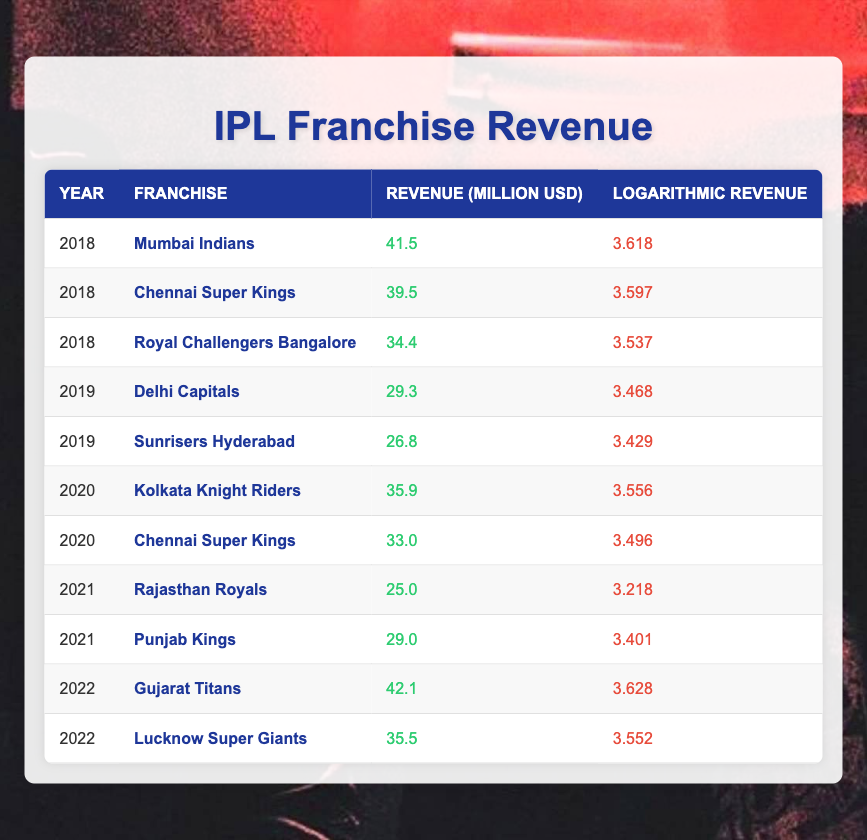What was the highest revenue generated by an IPL franchise in 2022? In 2022, the franchise with the highest revenue was Gujarat Titans, with a revenue of 42.1 million USD.
Answer: 42.1 million USD Which franchise had the lowest revenue in 2021? The franchise with the lowest revenue in 2021 was Rajasthan Royals, with a revenue of 25.0 million USD.
Answer: 25.0 million USD What is the total revenue generated by Chennai Super Kings from 2018 to 2020? Chennai Super Kings generated a revenue of 39.5 million USD in 2018, 33.0 million USD in 2020. The total revenue is 39.5 + 33.0 = 72.5 million USD.
Answer: 72.5 million USD True or False: Delhi Capitals had a higher revenue in 2019 than Royal Challengers Bangalore in 2018. Delhi Capitals' revenue in 2019 was 29.3 million USD, while Royal Challengers Bangalore's revenue in 2018 was 34.4 million USD. Since 29.3 million is less than 34.4 million, the statement is false.
Answer: False What was the average revenue of all franchises in 2020? The franchises in 2020 were Kolkata Knight Riders (35.9 million USD) and Chennai Super Kings (33.0 million USD). The total revenue is 35.9 + 33.0 = 68.9 million USD for two franchises, which gives an average of 68.9 / 2 = 34.45 million USD.
Answer: 34.45 million USD Which two franchises had a revenue greater than 40 million USD in 2018 and 2022? In 2018, Mumbai Indians had a revenue of 41.5 million USD. In 2022, Gujarat Titans had a revenue of 42.1 million USD. Hence, Mumbai Indians in 2018 and Gujarat Titans in 2022 both had revenues greater than 40 million USD.
Answer: Mumbai Indians and Gujarat Titans What was the trend in logarithmic revenue for Chennai Super Kings from 2018 to 2020? In 2018, Chennai Super Kings had a logarithmic revenue of 3.597, which decreased to 3.496 in 2020. This indicates a downward trend in logarithmic revenue over these years.
Answer: Downward trend How many franchises had a revenue of over 35 million USD in 2019? In 2019, only Delhi Capitals had a revenue of 29.3 million USD and Sunrisers Hyderabad had 26.8 million USD, which means no franchises reached over 35 million USD in that year.
Answer: 0 franchises 